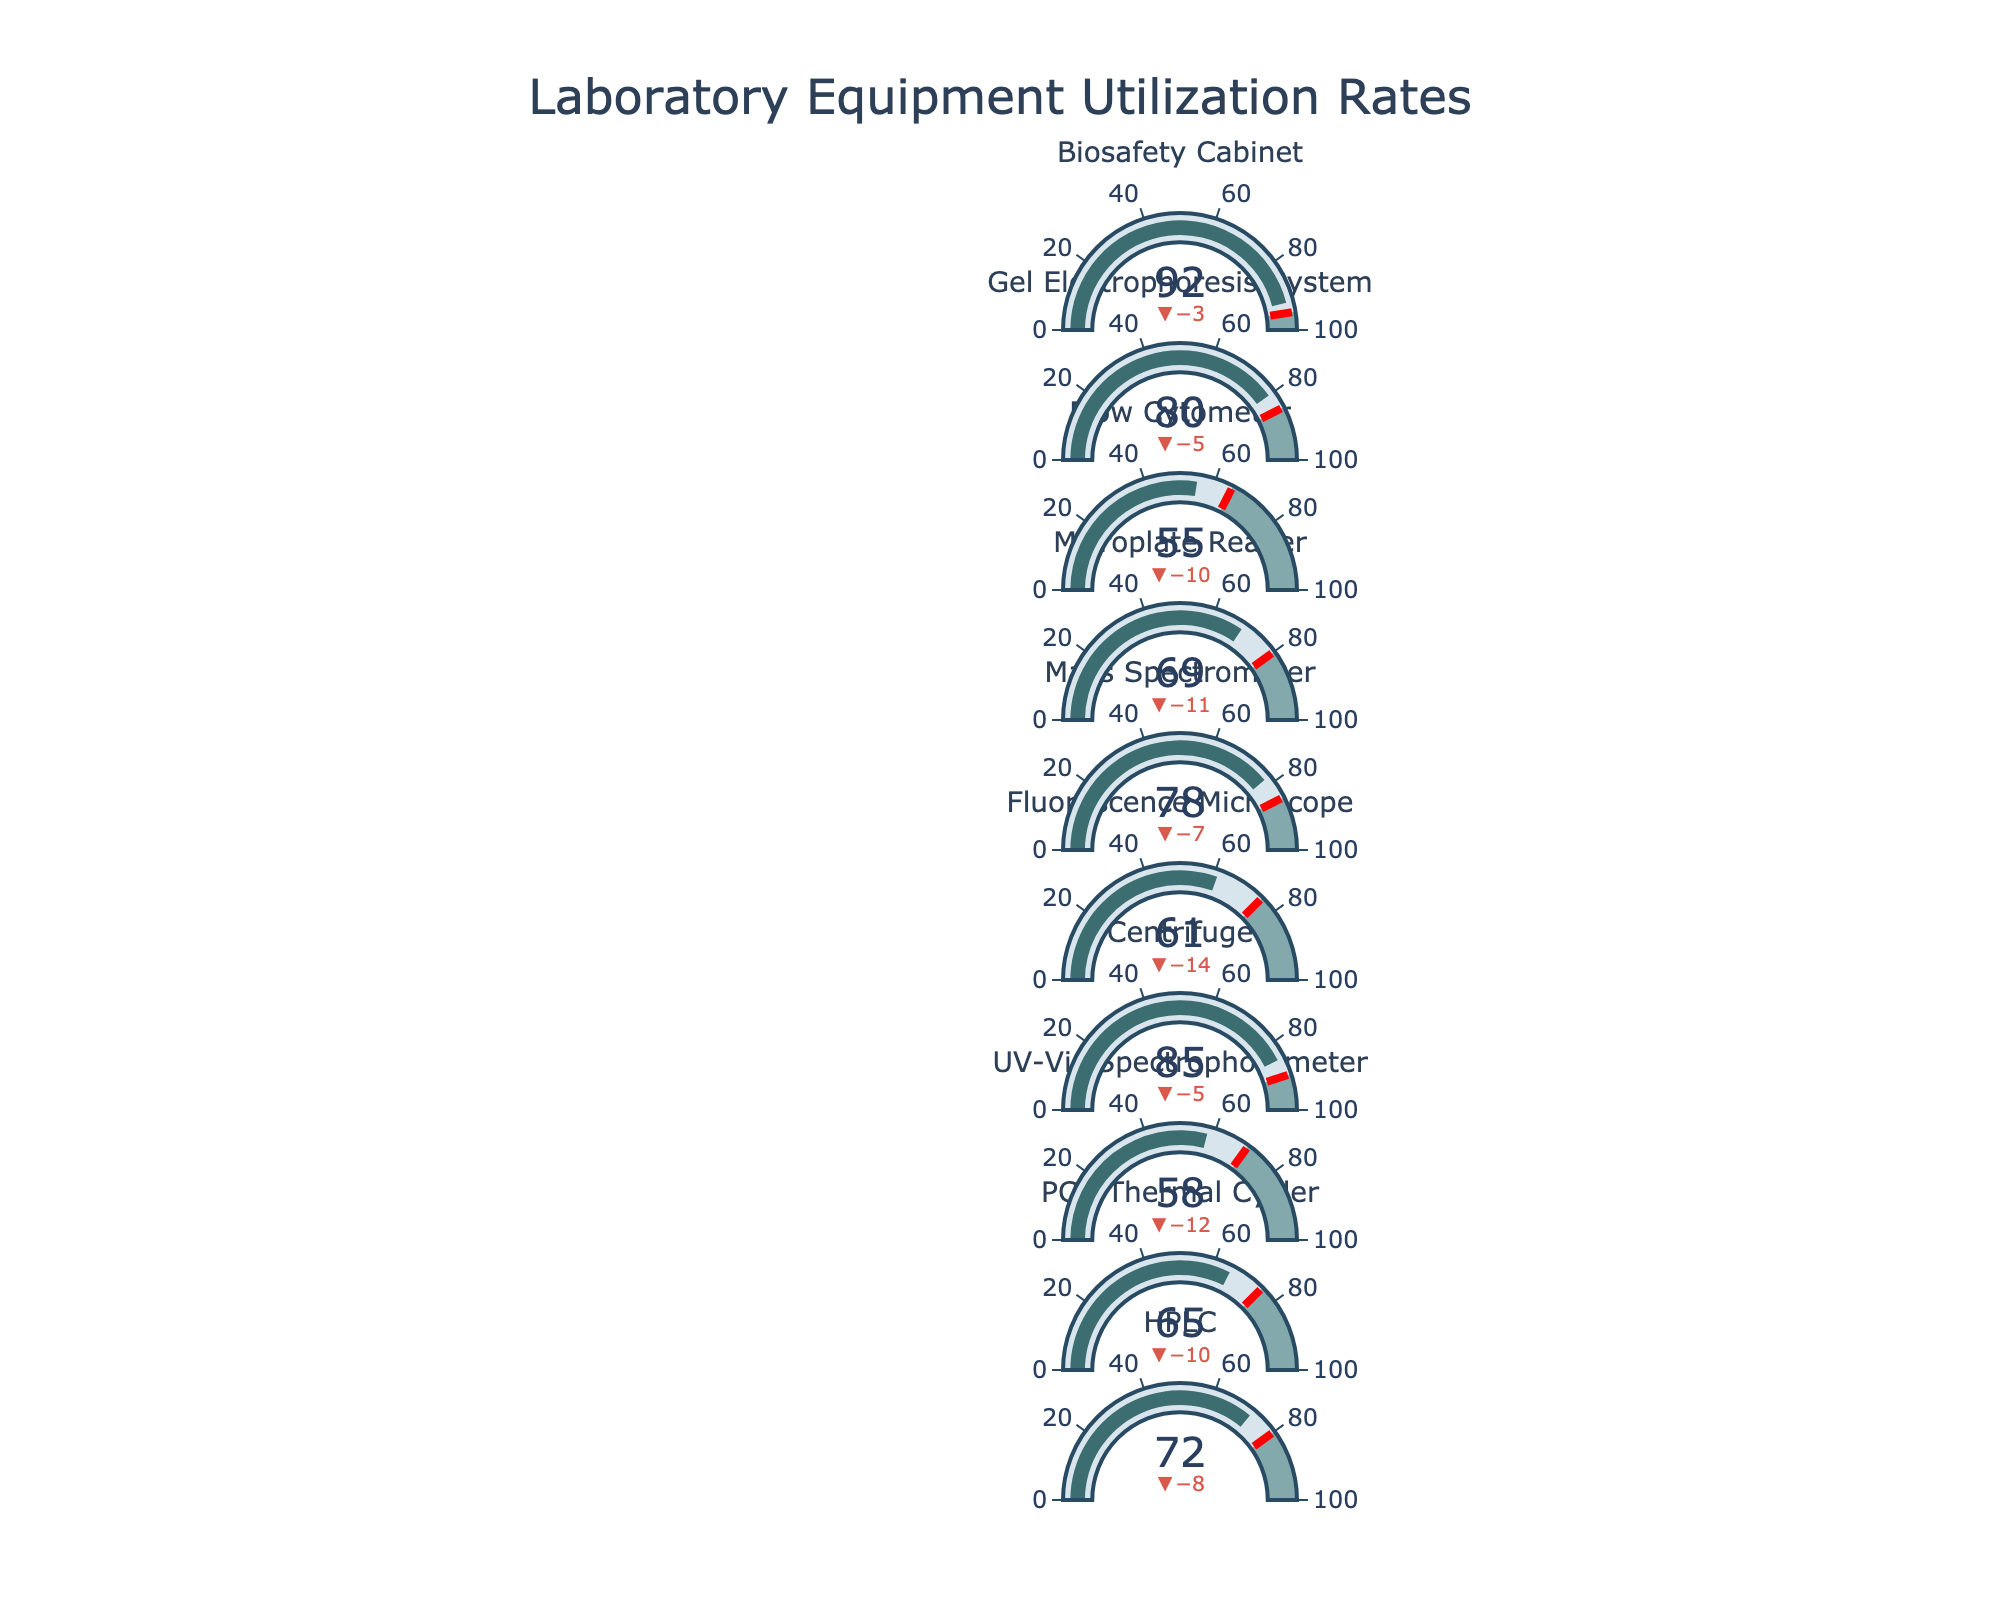What's the title of the figure? The title of the figure is displayed prominently at the top in a larger font size, indicating what the plot is about.
Answer: Laboratory Equipment Utilization Rates Which equipment has the highest actual usage percentage? By examining the values representing the actual usage percentage across all equipment, we see that the Biosafety Cabinet has the highest value.
Answer: Biosafety Cabinet What's the difference between the actual usage and target usage for the Flow Cytometer? The actual usage for the Flow Cytometer is 55%, and the target usage is 65%. The difference between these two values is calculated as 65 - 55.
Answer: 10% Which equipment's actual usage meets or exceeds its target usage? We need to compare the actual and target usage for each piece of equipment. Only those pieces of equipment whose actual value is greater than or equal to the target are selected. From the data, none of the equipment's actual usage meets or exceeds their target usage.
Answer: None What's the average actual usage percentage across all equipment? Add up all the actual usage percentages and divide by the number of data points: (72 + 65 + 58 + 85 + 61 + 78 + 69 + 55 + 80 + 92) / 10
Answer: 71.5% Which equipment is closest to its maximum capacity? The equipment closest to its maximum capacity will have the actual usage percentage closest to 100%. We compare all values and see that the Biosafety Cabinet has the highest actual usage percentage at 92%, which is closest to 100%.
Answer: Biosafety Cabinet What's the median of the target usage percentages? To find the median, we need to sort the target usage percentages and find the middle value. Sorted target values: [65, 70, 75, 75, 75, 80, 80, 85, 85, 95]. The median is the average of the 5th and 6th values: (75 + 75) / 2.
Answer: 75% Which two pieces of equipment have the smallest difference in their actual and target usage percentages? Calculate the absolute differences between actual and target usage for all equipment: HPLC (8), PCR Thermal Cycler (10), UV-Vis Spectrophotometer (12), Centrifuge (5), Fluorescence Microscope (14), Mass Spectrometer (7), Microplate Reader (11), Flow Cytometer (10), Gel Electrophoresis System (5), Biosafety Cabinet (3). The smallest differences are for the Centrifuge and Gel Electrophoresis System.
Answer: Centrifuge and Gel Electrophoresis System How many pieces of equipment have an actual usage percentage below 60%? Count the pieces of equipment where the actual usage percentage is less than 60%. These are PCR Thermal Cycler (65%), UV-Vis Spectrophotometer (58%), Fluorescence Microscope (61%), Flow Cytometer (55%).
Answer: Four 